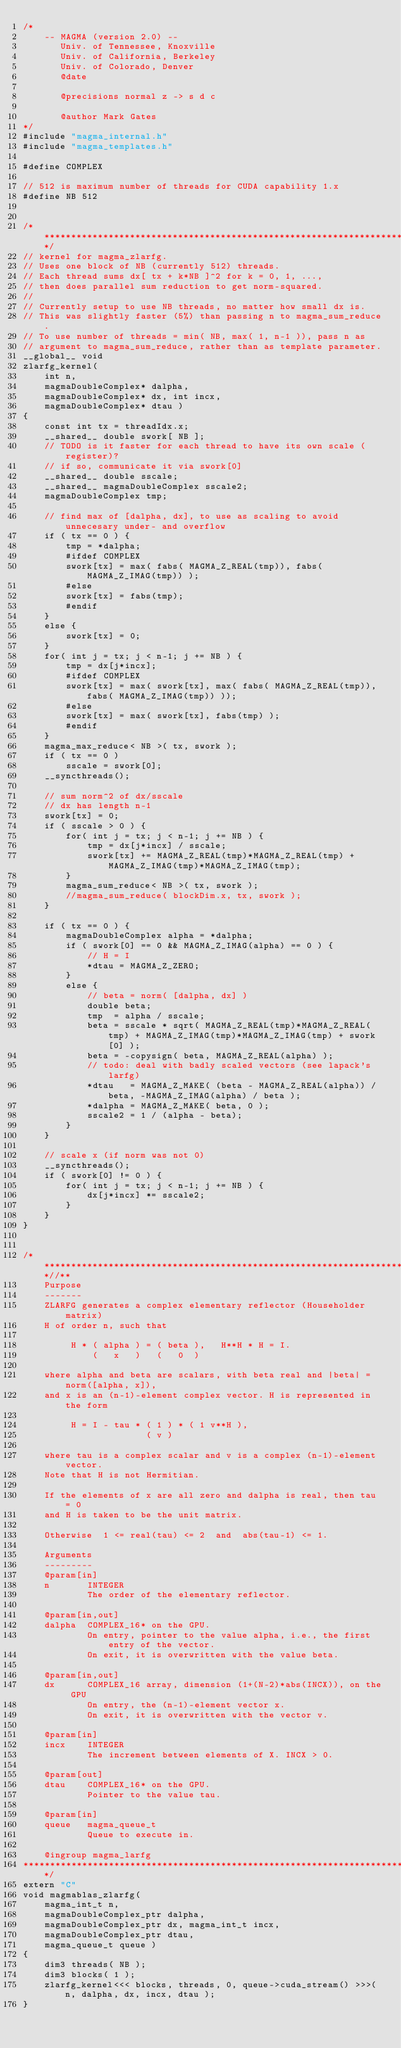Convert code to text. <code><loc_0><loc_0><loc_500><loc_500><_Cuda_>/*
    -- MAGMA (version 2.0) --
       Univ. of Tennessee, Knoxville
       Univ. of California, Berkeley
       Univ. of Colorado, Denver
       @date

       @precisions normal z -> s d c
       
       @author Mark Gates
*/
#include "magma_internal.h"
#include "magma_templates.h"

#define COMPLEX

// 512 is maximum number of threads for CUDA capability 1.x
#define NB 512


/******************************************************************************/
// kernel for magma_zlarfg.
// Uses one block of NB (currently 512) threads.
// Each thread sums dx[ tx + k*NB ]^2 for k = 0, 1, ...,
// then does parallel sum reduction to get norm-squared.
// 
// Currently setup to use NB threads, no matter how small dx is.
// This was slightly faster (5%) than passing n to magma_sum_reduce.
// To use number of threads = min( NB, max( 1, n-1 )), pass n as
// argument to magma_sum_reduce, rather than as template parameter.
__global__ void
zlarfg_kernel(
    int n,
    magmaDoubleComplex* dalpha,
    magmaDoubleComplex* dx, int incx,
    magmaDoubleComplex* dtau )
{
    const int tx = threadIdx.x;
    __shared__ double swork[ NB ];
    // TODO is it faster for each thread to have its own scale (register)?
    // if so, communicate it via swork[0]
    __shared__ double sscale;
    __shared__ magmaDoubleComplex sscale2;
    magmaDoubleComplex tmp;
    
    // find max of [dalpha, dx], to use as scaling to avoid unnecesary under- and overflow
    if ( tx == 0 ) {
        tmp = *dalpha;
        #ifdef COMPLEX
        swork[tx] = max( fabs( MAGMA_Z_REAL(tmp)), fabs( MAGMA_Z_IMAG(tmp)) );
        #else
        swork[tx] = fabs(tmp);
        #endif
    }
    else {
        swork[tx] = 0;
    }
    for( int j = tx; j < n-1; j += NB ) {
        tmp = dx[j*incx];
        #ifdef COMPLEX
        swork[tx] = max( swork[tx], max( fabs( MAGMA_Z_REAL(tmp)), fabs( MAGMA_Z_IMAG(tmp)) ));
        #else
        swork[tx] = max( swork[tx], fabs(tmp) );
        #endif
    }
    magma_max_reduce< NB >( tx, swork );
    if ( tx == 0 )
        sscale = swork[0];
    __syncthreads();
    
    // sum norm^2 of dx/sscale
    // dx has length n-1
    swork[tx] = 0;
    if ( sscale > 0 ) {
        for( int j = tx; j < n-1; j += NB ) {
            tmp = dx[j*incx] / sscale;
            swork[tx] += MAGMA_Z_REAL(tmp)*MAGMA_Z_REAL(tmp) + MAGMA_Z_IMAG(tmp)*MAGMA_Z_IMAG(tmp);
        }
        magma_sum_reduce< NB >( tx, swork );
        //magma_sum_reduce( blockDim.x, tx, swork );
    }
    
    if ( tx == 0 ) {
        magmaDoubleComplex alpha = *dalpha;
        if ( swork[0] == 0 && MAGMA_Z_IMAG(alpha) == 0 ) {
            // H = I
            *dtau = MAGMA_Z_ZERO;
        }
        else {
            // beta = norm( [dalpha, dx] )
            double beta;
            tmp  = alpha / sscale;
            beta = sscale * sqrt( MAGMA_Z_REAL(tmp)*MAGMA_Z_REAL(tmp) + MAGMA_Z_IMAG(tmp)*MAGMA_Z_IMAG(tmp) + swork[0] );
            beta = -copysign( beta, MAGMA_Z_REAL(alpha) );
            // todo: deal with badly scaled vectors (see lapack's larfg)
            *dtau   = MAGMA_Z_MAKE( (beta - MAGMA_Z_REAL(alpha)) / beta, -MAGMA_Z_IMAG(alpha) / beta );
            *dalpha = MAGMA_Z_MAKE( beta, 0 );
            sscale2 = 1 / (alpha - beta);
        }
    }
    
    // scale x (if norm was not 0)
    __syncthreads();
    if ( swork[0] != 0 ) {
        for( int j = tx; j < n-1; j += NB ) {
            dx[j*incx] *= sscale2;
        }
    }
}


/***************************************************************************//**
    Purpose
    -------
    ZLARFG generates a complex elementary reflector (Householder matrix)
    H of order n, such that

         H * ( alpha ) = ( beta ),   H**H * H = I.
             (   x   )   (   0  )

    where alpha and beta are scalars, with beta real and |beta| = norm([alpha, x]),
    and x is an (n-1)-element complex vector. H is represented in the form

         H = I - tau * ( 1 ) * ( 1 v**H ),
                       ( v )

    where tau is a complex scalar and v is a complex (n-1)-element vector.
    Note that H is not Hermitian.

    If the elements of x are all zero and dalpha is real, then tau = 0
    and H is taken to be the unit matrix.

    Otherwise  1 <= real(tau) <= 2  and  abs(tau-1) <= 1.

    Arguments
    ---------
    @param[in]
    n       INTEGER
            The order of the elementary reflector.

    @param[in,out]
    dalpha  COMPLEX_16* on the GPU.
            On entry, pointer to the value alpha, i.e., the first entry of the vector.
            On exit, it is overwritten with the value beta.

    @param[in,out]
    dx      COMPLEX_16 array, dimension (1+(N-2)*abs(INCX)), on the GPU
            On entry, the (n-1)-element vector x.
            On exit, it is overwritten with the vector v.

    @param[in]
    incx    INTEGER
            The increment between elements of X. INCX > 0.

    @param[out]
    dtau    COMPLEX_16* on the GPU.
            Pointer to the value tau.

    @param[in]
    queue   magma_queue_t
            Queue to execute in.

    @ingroup magma_larfg
*******************************************************************************/
extern "C"
void magmablas_zlarfg(
    magma_int_t n,
    magmaDoubleComplex_ptr dalpha,
    magmaDoubleComplex_ptr dx, magma_int_t incx,
    magmaDoubleComplex_ptr dtau,
    magma_queue_t queue )
{
    dim3 threads( NB );
    dim3 blocks( 1 );
    zlarfg_kernel<<< blocks, threads, 0, queue->cuda_stream() >>>( n, dalpha, dx, incx, dtau );
}
</code> 